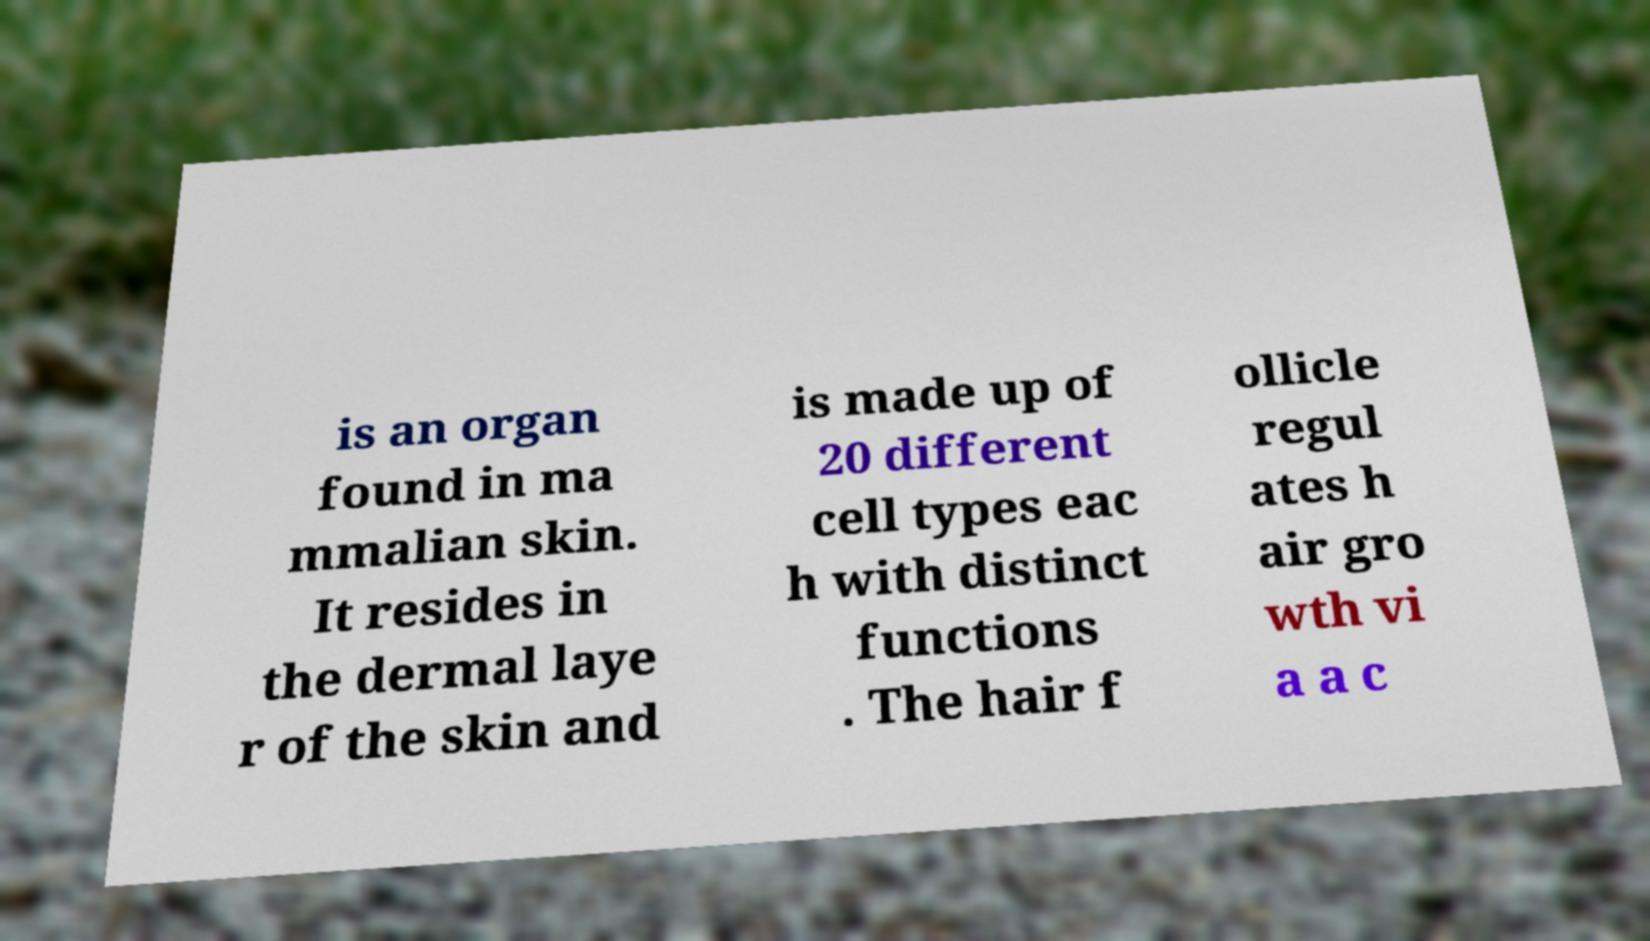Can you read and provide the text displayed in the image?This photo seems to have some interesting text. Can you extract and type it out for me? is an organ found in ma mmalian skin. It resides in the dermal laye r of the skin and is made up of 20 different cell types eac h with distinct functions . The hair f ollicle regul ates h air gro wth vi a a c 